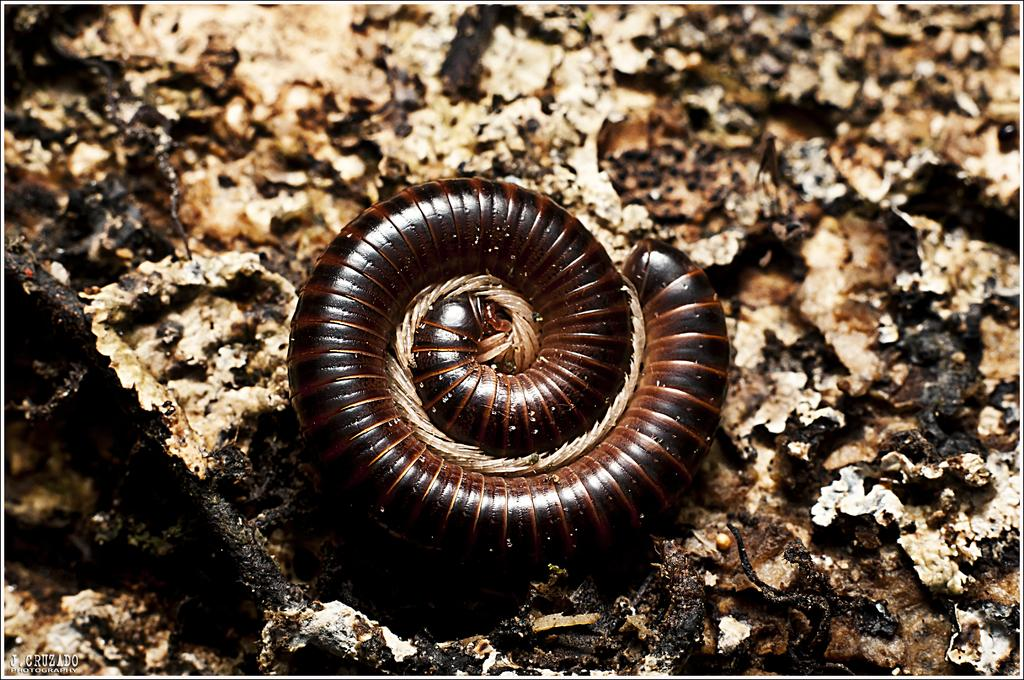What type of creature can be seen in the image? There is an animal in the image. Where is the animal located in the image? The animal is on the ground. What type of feather can be seen on the animal in the image? There is no feather visible on the animal in the image. What type of alley is the animal walking through in the image? There is no alley present in the image; it only shows the animal on the ground. 